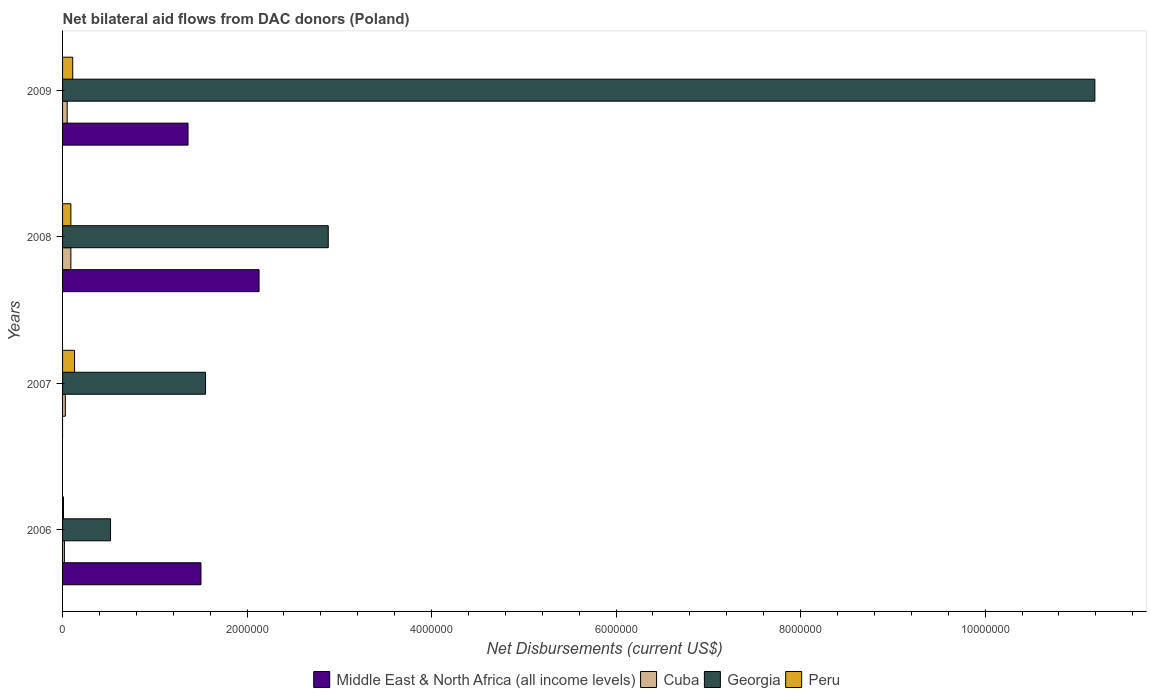How many groups of bars are there?
Your response must be concise. 4. Are the number of bars on each tick of the Y-axis equal?
Offer a very short reply. No. How many bars are there on the 3rd tick from the top?
Your response must be concise. 3. How many bars are there on the 2nd tick from the bottom?
Give a very brief answer. 3. What is the label of the 1st group of bars from the top?
Provide a short and direct response. 2009. In how many cases, is the number of bars for a given year not equal to the number of legend labels?
Provide a short and direct response. 1. What is the net bilateral aid flows in Georgia in 2007?
Your answer should be very brief. 1.55e+06. Across all years, what is the maximum net bilateral aid flows in Peru?
Your answer should be very brief. 1.30e+05. In which year was the net bilateral aid flows in Georgia maximum?
Offer a terse response. 2009. What is the total net bilateral aid flows in Georgia in the graph?
Offer a terse response. 1.61e+07. What is the difference between the net bilateral aid flows in Cuba in 2007 and that in 2008?
Provide a short and direct response. -6.00e+04. What is the difference between the net bilateral aid flows in Middle East & North Africa (all income levels) in 2006 and the net bilateral aid flows in Cuba in 2009?
Make the answer very short. 1.45e+06. What is the average net bilateral aid flows in Peru per year?
Keep it short and to the point. 8.50e+04. In the year 2007, what is the difference between the net bilateral aid flows in Cuba and net bilateral aid flows in Georgia?
Offer a very short reply. -1.52e+06. In how many years, is the net bilateral aid flows in Middle East & North Africa (all income levels) greater than 3600000 US$?
Your response must be concise. 0. What is the ratio of the net bilateral aid flows in Middle East & North Africa (all income levels) in 2006 to that in 2009?
Your answer should be very brief. 1.1. Is the difference between the net bilateral aid flows in Cuba in 2006 and 2009 greater than the difference between the net bilateral aid flows in Georgia in 2006 and 2009?
Offer a terse response. Yes. What is the difference between the highest and the second highest net bilateral aid flows in Middle East & North Africa (all income levels)?
Your response must be concise. 6.30e+05. What is the difference between the highest and the lowest net bilateral aid flows in Georgia?
Your answer should be very brief. 1.07e+07. In how many years, is the net bilateral aid flows in Peru greater than the average net bilateral aid flows in Peru taken over all years?
Your response must be concise. 3. Is it the case that in every year, the sum of the net bilateral aid flows in Peru and net bilateral aid flows in Cuba is greater than the net bilateral aid flows in Middle East & North Africa (all income levels)?
Provide a succinct answer. No. How many bars are there?
Your answer should be very brief. 15. What is the difference between two consecutive major ticks on the X-axis?
Give a very brief answer. 2.00e+06. Are the values on the major ticks of X-axis written in scientific E-notation?
Your answer should be compact. No. Does the graph contain any zero values?
Keep it short and to the point. Yes. How are the legend labels stacked?
Keep it short and to the point. Horizontal. What is the title of the graph?
Make the answer very short. Net bilateral aid flows from DAC donors (Poland). Does "South Africa" appear as one of the legend labels in the graph?
Your answer should be very brief. No. What is the label or title of the X-axis?
Your answer should be compact. Net Disbursements (current US$). What is the label or title of the Y-axis?
Your response must be concise. Years. What is the Net Disbursements (current US$) of Middle East & North Africa (all income levels) in 2006?
Offer a very short reply. 1.50e+06. What is the Net Disbursements (current US$) in Georgia in 2006?
Your answer should be very brief. 5.20e+05. What is the Net Disbursements (current US$) of Peru in 2006?
Offer a terse response. 10000. What is the Net Disbursements (current US$) of Cuba in 2007?
Ensure brevity in your answer.  3.00e+04. What is the Net Disbursements (current US$) in Georgia in 2007?
Offer a terse response. 1.55e+06. What is the Net Disbursements (current US$) of Middle East & North Africa (all income levels) in 2008?
Your answer should be compact. 2.13e+06. What is the Net Disbursements (current US$) of Cuba in 2008?
Make the answer very short. 9.00e+04. What is the Net Disbursements (current US$) of Georgia in 2008?
Provide a short and direct response. 2.88e+06. What is the Net Disbursements (current US$) of Peru in 2008?
Ensure brevity in your answer.  9.00e+04. What is the Net Disbursements (current US$) of Middle East & North Africa (all income levels) in 2009?
Your answer should be very brief. 1.36e+06. What is the Net Disbursements (current US$) of Cuba in 2009?
Make the answer very short. 5.00e+04. What is the Net Disbursements (current US$) of Georgia in 2009?
Your answer should be very brief. 1.12e+07. What is the Net Disbursements (current US$) in Peru in 2009?
Make the answer very short. 1.10e+05. Across all years, what is the maximum Net Disbursements (current US$) of Middle East & North Africa (all income levels)?
Provide a succinct answer. 2.13e+06. Across all years, what is the maximum Net Disbursements (current US$) in Cuba?
Keep it short and to the point. 9.00e+04. Across all years, what is the maximum Net Disbursements (current US$) in Georgia?
Offer a very short reply. 1.12e+07. Across all years, what is the minimum Net Disbursements (current US$) of Georgia?
Your answer should be compact. 5.20e+05. Across all years, what is the minimum Net Disbursements (current US$) in Peru?
Your response must be concise. 10000. What is the total Net Disbursements (current US$) of Middle East & North Africa (all income levels) in the graph?
Offer a terse response. 4.99e+06. What is the total Net Disbursements (current US$) of Georgia in the graph?
Offer a terse response. 1.61e+07. What is the total Net Disbursements (current US$) of Peru in the graph?
Your response must be concise. 3.40e+05. What is the difference between the Net Disbursements (current US$) in Cuba in 2006 and that in 2007?
Make the answer very short. -10000. What is the difference between the Net Disbursements (current US$) in Georgia in 2006 and that in 2007?
Make the answer very short. -1.03e+06. What is the difference between the Net Disbursements (current US$) in Peru in 2006 and that in 2007?
Provide a succinct answer. -1.20e+05. What is the difference between the Net Disbursements (current US$) in Middle East & North Africa (all income levels) in 2006 and that in 2008?
Provide a short and direct response. -6.30e+05. What is the difference between the Net Disbursements (current US$) in Cuba in 2006 and that in 2008?
Give a very brief answer. -7.00e+04. What is the difference between the Net Disbursements (current US$) of Georgia in 2006 and that in 2008?
Ensure brevity in your answer.  -2.36e+06. What is the difference between the Net Disbursements (current US$) in Georgia in 2006 and that in 2009?
Provide a short and direct response. -1.07e+07. What is the difference between the Net Disbursements (current US$) in Peru in 2006 and that in 2009?
Your answer should be very brief. -1.00e+05. What is the difference between the Net Disbursements (current US$) of Georgia in 2007 and that in 2008?
Your response must be concise. -1.33e+06. What is the difference between the Net Disbursements (current US$) in Peru in 2007 and that in 2008?
Provide a short and direct response. 4.00e+04. What is the difference between the Net Disbursements (current US$) in Georgia in 2007 and that in 2009?
Your answer should be compact. -9.64e+06. What is the difference between the Net Disbursements (current US$) of Peru in 2007 and that in 2009?
Offer a very short reply. 2.00e+04. What is the difference between the Net Disbursements (current US$) in Middle East & North Africa (all income levels) in 2008 and that in 2009?
Offer a terse response. 7.70e+05. What is the difference between the Net Disbursements (current US$) in Georgia in 2008 and that in 2009?
Provide a succinct answer. -8.31e+06. What is the difference between the Net Disbursements (current US$) of Middle East & North Africa (all income levels) in 2006 and the Net Disbursements (current US$) of Cuba in 2007?
Ensure brevity in your answer.  1.47e+06. What is the difference between the Net Disbursements (current US$) in Middle East & North Africa (all income levels) in 2006 and the Net Disbursements (current US$) in Peru in 2007?
Your answer should be very brief. 1.37e+06. What is the difference between the Net Disbursements (current US$) in Cuba in 2006 and the Net Disbursements (current US$) in Georgia in 2007?
Provide a short and direct response. -1.53e+06. What is the difference between the Net Disbursements (current US$) of Cuba in 2006 and the Net Disbursements (current US$) of Peru in 2007?
Offer a terse response. -1.10e+05. What is the difference between the Net Disbursements (current US$) in Middle East & North Africa (all income levels) in 2006 and the Net Disbursements (current US$) in Cuba in 2008?
Your answer should be very brief. 1.41e+06. What is the difference between the Net Disbursements (current US$) in Middle East & North Africa (all income levels) in 2006 and the Net Disbursements (current US$) in Georgia in 2008?
Make the answer very short. -1.38e+06. What is the difference between the Net Disbursements (current US$) in Middle East & North Africa (all income levels) in 2006 and the Net Disbursements (current US$) in Peru in 2008?
Keep it short and to the point. 1.41e+06. What is the difference between the Net Disbursements (current US$) of Cuba in 2006 and the Net Disbursements (current US$) of Georgia in 2008?
Offer a terse response. -2.86e+06. What is the difference between the Net Disbursements (current US$) of Georgia in 2006 and the Net Disbursements (current US$) of Peru in 2008?
Keep it short and to the point. 4.30e+05. What is the difference between the Net Disbursements (current US$) of Middle East & North Africa (all income levels) in 2006 and the Net Disbursements (current US$) of Cuba in 2009?
Your answer should be compact. 1.45e+06. What is the difference between the Net Disbursements (current US$) of Middle East & North Africa (all income levels) in 2006 and the Net Disbursements (current US$) of Georgia in 2009?
Ensure brevity in your answer.  -9.69e+06. What is the difference between the Net Disbursements (current US$) in Middle East & North Africa (all income levels) in 2006 and the Net Disbursements (current US$) in Peru in 2009?
Provide a succinct answer. 1.39e+06. What is the difference between the Net Disbursements (current US$) in Cuba in 2006 and the Net Disbursements (current US$) in Georgia in 2009?
Your answer should be very brief. -1.12e+07. What is the difference between the Net Disbursements (current US$) of Cuba in 2007 and the Net Disbursements (current US$) of Georgia in 2008?
Provide a short and direct response. -2.85e+06. What is the difference between the Net Disbursements (current US$) of Cuba in 2007 and the Net Disbursements (current US$) of Peru in 2008?
Provide a succinct answer. -6.00e+04. What is the difference between the Net Disbursements (current US$) of Georgia in 2007 and the Net Disbursements (current US$) of Peru in 2008?
Ensure brevity in your answer.  1.46e+06. What is the difference between the Net Disbursements (current US$) of Cuba in 2007 and the Net Disbursements (current US$) of Georgia in 2009?
Offer a very short reply. -1.12e+07. What is the difference between the Net Disbursements (current US$) in Cuba in 2007 and the Net Disbursements (current US$) in Peru in 2009?
Your answer should be compact. -8.00e+04. What is the difference between the Net Disbursements (current US$) of Georgia in 2007 and the Net Disbursements (current US$) of Peru in 2009?
Provide a short and direct response. 1.44e+06. What is the difference between the Net Disbursements (current US$) of Middle East & North Africa (all income levels) in 2008 and the Net Disbursements (current US$) of Cuba in 2009?
Your answer should be very brief. 2.08e+06. What is the difference between the Net Disbursements (current US$) of Middle East & North Africa (all income levels) in 2008 and the Net Disbursements (current US$) of Georgia in 2009?
Provide a short and direct response. -9.06e+06. What is the difference between the Net Disbursements (current US$) in Middle East & North Africa (all income levels) in 2008 and the Net Disbursements (current US$) in Peru in 2009?
Your answer should be very brief. 2.02e+06. What is the difference between the Net Disbursements (current US$) of Cuba in 2008 and the Net Disbursements (current US$) of Georgia in 2009?
Your answer should be very brief. -1.11e+07. What is the difference between the Net Disbursements (current US$) in Cuba in 2008 and the Net Disbursements (current US$) in Peru in 2009?
Offer a very short reply. -2.00e+04. What is the difference between the Net Disbursements (current US$) in Georgia in 2008 and the Net Disbursements (current US$) in Peru in 2009?
Ensure brevity in your answer.  2.77e+06. What is the average Net Disbursements (current US$) of Middle East & North Africa (all income levels) per year?
Your answer should be very brief. 1.25e+06. What is the average Net Disbursements (current US$) of Cuba per year?
Provide a short and direct response. 4.75e+04. What is the average Net Disbursements (current US$) in Georgia per year?
Your answer should be compact. 4.04e+06. What is the average Net Disbursements (current US$) of Peru per year?
Your response must be concise. 8.50e+04. In the year 2006, what is the difference between the Net Disbursements (current US$) in Middle East & North Africa (all income levels) and Net Disbursements (current US$) in Cuba?
Offer a very short reply. 1.48e+06. In the year 2006, what is the difference between the Net Disbursements (current US$) of Middle East & North Africa (all income levels) and Net Disbursements (current US$) of Georgia?
Keep it short and to the point. 9.80e+05. In the year 2006, what is the difference between the Net Disbursements (current US$) in Middle East & North Africa (all income levels) and Net Disbursements (current US$) in Peru?
Provide a succinct answer. 1.49e+06. In the year 2006, what is the difference between the Net Disbursements (current US$) in Cuba and Net Disbursements (current US$) in Georgia?
Provide a succinct answer. -5.00e+05. In the year 2006, what is the difference between the Net Disbursements (current US$) of Cuba and Net Disbursements (current US$) of Peru?
Provide a succinct answer. 10000. In the year 2006, what is the difference between the Net Disbursements (current US$) in Georgia and Net Disbursements (current US$) in Peru?
Offer a very short reply. 5.10e+05. In the year 2007, what is the difference between the Net Disbursements (current US$) of Cuba and Net Disbursements (current US$) of Georgia?
Your answer should be compact. -1.52e+06. In the year 2007, what is the difference between the Net Disbursements (current US$) of Cuba and Net Disbursements (current US$) of Peru?
Make the answer very short. -1.00e+05. In the year 2007, what is the difference between the Net Disbursements (current US$) in Georgia and Net Disbursements (current US$) in Peru?
Give a very brief answer. 1.42e+06. In the year 2008, what is the difference between the Net Disbursements (current US$) of Middle East & North Africa (all income levels) and Net Disbursements (current US$) of Cuba?
Make the answer very short. 2.04e+06. In the year 2008, what is the difference between the Net Disbursements (current US$) of Middle East & North Africa (all income levels) and Net Disbursements (current US$) of Georgia?
Your response must be concise. -7.50e+05. In the year 2008, what is the difference between the Net Disbursements (current US$) of Middle East & North Africa (all income levels) and Net Disbursements (current US$) of Peru?
Offer a very short reply. 2.04e+06. In the year 2008, what is the difference between the Net Disbursements (current US$) in Cuba and Net Disbursements (current US$) in Georgia?
Offer a terse response. -2.79e+06. In the year 2008, what is the difference between the Net Disbursements (current US$) of Cuba and Net Disbursements (current US$) of Peru?
Keep it short and to the point. 0. In the year 2008, what is the difference between the Net Disbursements (current US$) in Georgia and Net Disbursements (current US$) in Peru?
Provide a succinct answer. 2.79e+06. In the year 2009, what is the difference between the Net Disbursements (current US$) in Middle East & North Africa (all income levels) and Net Disbursements (current US$) in Cuba?
Your answer should be very brief. 1.31e+06. In the year 2009, what is the difference between the Net Disbursements (current US$) in Middle East & North Africa (all income levels) and Net Disbursements (current US$) in Georgia?
Ensure brevity in your answer.  -9.83e+06. In the year 2009, what is the difference between the Net Disbursements (current US$) in Middle East & North Africa (all income levels) and Net Disbursements (current US$) in Peru?
Provide a succinct answer. 1.25e+06. In the year 2009, what is the difference between the Net Disbursements (current US$) in Cuba and Net Disbursements (current US$) in Georgia?
Offer a terse response. -1.11e+07. In the year 2009, what is the difference between the Net Disbursements (current US$) in Cuba and Net Disbursements (current US$) in Peru?
Give a very brief answer. -6.00e+04. In the year 2009, what is the difference between the Net Disbursements (current US$) of Georgia and Net Disbursements (current US$) of Peru?
Keep it short and to the point. 1.11e+07. What is the ratio of the Net Disbursements (current US$) in Cuba in 2006 to that in 2007?
Your answer should be very brief. 0.67. What is the ratio of the Net Disbursements (current US$) in Georgia in 2006 to that in 2007?
Make the answer very short. 0.34. What is the ratio of the Net Disbursements (current US$) in Peru in 2006 to that in 2007?
Provide a short and direct response. 0.08. What is the ratio of the Net Disbursements (current US$) of Middle East & North Africa (all income levels) in 2006 to that in 2008?
Provide a succinct answer. 0.7. What is the ratio of the Net Disbursements (current US$) in Cuba in 2006 to that in 2008?
Keep it short and to the point. 0.22. What is the ratio of the Net Disbursements (current US$) in Georgia in 2006 to that in 2008?
Offer a very short reply. 0.18. What is the ratio of the Net Disbursements (current US$) in Middle East & North Africa (all income levels) in 2006 to that in 2009?
Your answer should be very brief. 1.1. What is the ratio of the Net Disbursements (current US$) of Georgia in 2006 to that in 2009?
Keep it short and to the point. 0.05. What is the ratio of the Net Disbursements (current US$) in Peru in 2006 to that in 2009?
Give a very brief answer. 0.09. What is the ratio of the Net Disbursements (current US$) in Cuba in 2007 to that in 2008?
Make the answer very short. 0.33. What is the ratio of the Net Disbursements (current US$) of Georgia in 2007 to that in 2008?
Keep it short and to the point. 0.54. What is the ratio of the Net Disbursements (current US$) in Peru in 2007 to that in 2008?
Make the answer very short. 1.44. What is the ratio of the Net Disbursements (current US$) in Georgia in 2007 to that in 2009?
Keep it short and to the point. 0.14. What is the ratio of the Net Disbursements (current US$) in Peru in 2007 to that in 2009?
Provide a succinct answer. 1.18. What is the ratio of the Net Disbursements (current US$) of Middle East & North Africa (all income levels) in 2008 to that in 2009?
Make the answer very short. 1.57. What is the ratio of the Net Disbursements (current US$) in Cuba in 2008 to that in 2009?
Offer a terse response. 1.8. What is the ratio of the Net Disbursements (current US$) in Georgia in 2008 to that in 2009?
Your answer should be compact. 0.26. What is the ratio of the Net Disbursements (current US$) in Peru in 2008 to that in 2009?
Keep it short and to the point. 0.82. What is the difference between the highest and the second highest Net Disbursements (current US$) of Middle East & North Africa (all income levels)?
Give a very brief answer. 6.30e+05. What is the difference between the highest and the second highest Net Disbursements (current US$) of Georgia?
Offer a very short reply. 8.31e+06. What is the difference between the highest and the lowest Net Disbursements (current US$) in Middle East & North Africa (all income levels)?
Ensure brevity in your answer.  2.13e+06. What is the difference between the highest and the lowest Net Disbursements (current US$) of Cuba?
Ensure brevity in your answer.  7.00e+04. What is the difference between the highest and the lowest Net Disbursements (current US$) of Georgia?
Make the answer very short. 1.07e+07. 